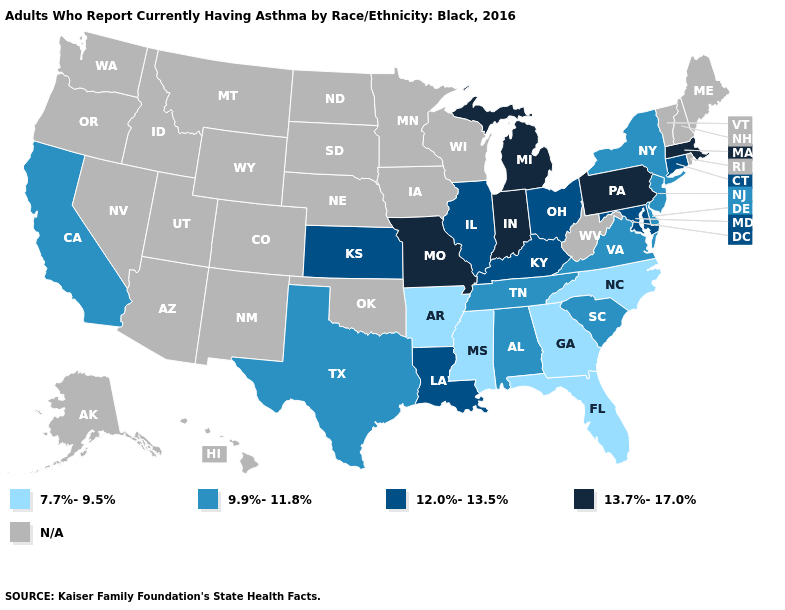What is the highest value in states that border Kentucky?
Keep it brief. 13.7%-17.0%. Name the states that have a value in the range 9.9%-11.8%?
Concise answer only. Alabama, California, Delaware, New Jersey, New York, South Carolina, Tennessee, Texas, Virginia. What is the value of South Carolina?
Keep it brief. 9.9%-11.8%. Among the states that border Maryland , does Pennsylvania have the lowest value?
Concise answer only. No. What is the value of North Carolina?
Short answer required. 7.7%-9.5%. What is the value of Utah?
Be succinct. N/A. What is the lowest value in the West?
Answer briefly. 9.9%-11.8%. Among the states that border Connecticut , which have the lowest value?
Write a very short answer. New York. Name the states that have a value in the range 12.0%-13.5%?
Short answer required. Connecticut, Illinois, Kansas, Kentucky, Louisiana, Maryland, Ohio. What is the highest value in the USA?
Give a very brief answer. 13.7%-17.0%. Among the states that border Massachusetts , which have the lowest value?
Give a very brief answer. New York. Name the states that have a value in the range N/A?
Short answer required. Alaska, Arizona, Colorado, Hawaii, Idaho, Iowa, Maine, Minnesota, Montana, Nebraska, Nevada, New Hampshire, New Mexico, North Dakota, Oklahoma, Oregon, Rhode Island, South Dakota, Utah, Vermont, Washington, West Virginia, Wisconsin, Wyoming. What is the lowest value in the USA?
Concise answer only. 7.7%-9.5%. 